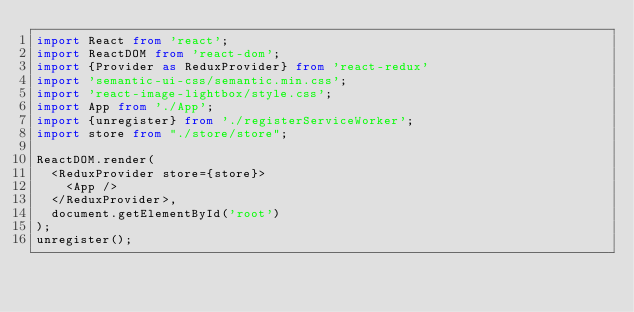<code> <loc_0><loc_0><loc_500><loc_500><_TypeScript_>import React from 'react';
import ReactDOM from 'react-dom';
import {Provider as ReduxProvider} from 'react-redux'
import 'semantic-ui-css/semantic.min.css';
import 'react-image-lightbox/style.css';
import App from './App';
import {unregister} from './registerServiceWorker';
import store from "./store/store";

ReactDOM.render(
  <ReduxProvider store={store}>
    <App />
  </ReduxProvider>,
  document.getElementById('root')
);
unregister();
</code> 